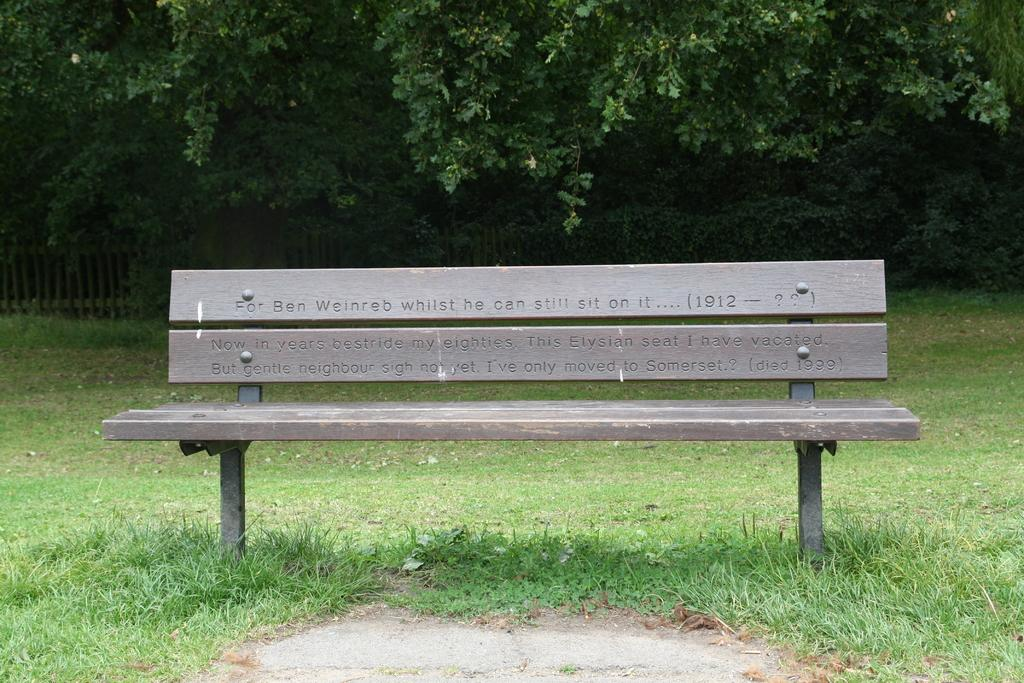What type of seating is visible in the image? There is a wooden bench in the image. What is written or engraved on the bench? The bench has words and numbers on it. What type of ground is visible at the bottom of the image? There is grass at the bottom of the image. What can be seen in the background of the image? There are trees and a fence in the background of the image. What type of shop can be seen in the image? There is no shop present in the image; it features a wooden bench, grass, trees, and a fence in the background. 